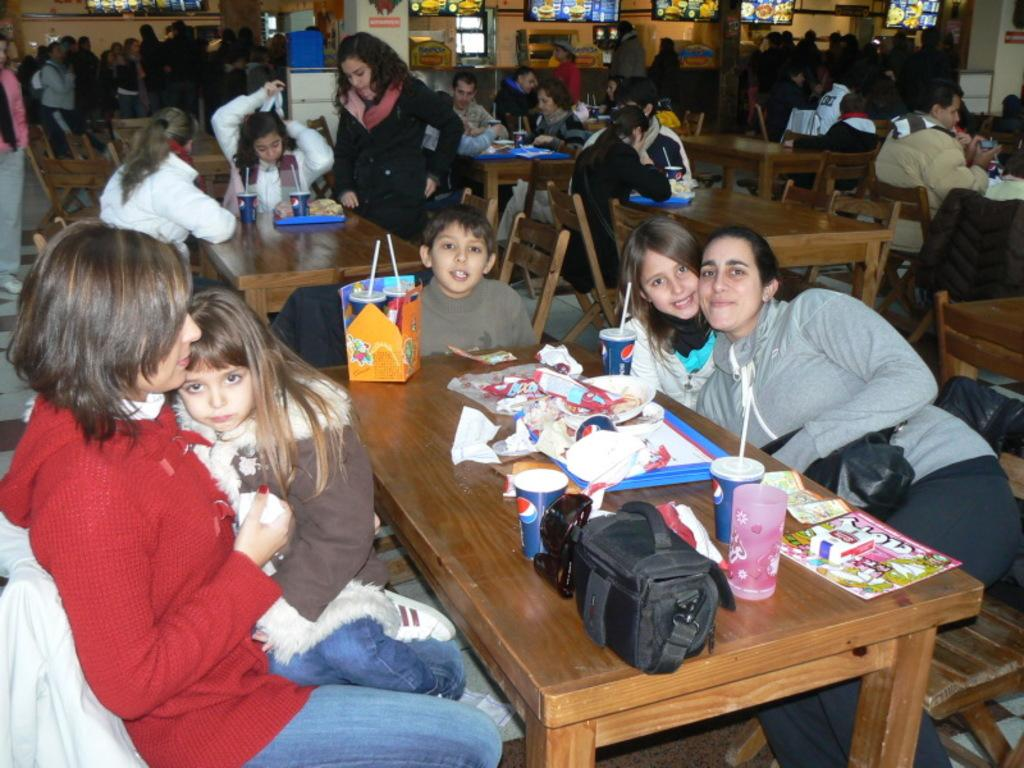How many people are in the image? There are multiple persons in the image. What are some of the people doing in the image? Some of the persons are sitting on chairs, while at least one person is standing on the floor. What is the color of the background in the image? The background color is yellow. What type of alarm can be heard going off in the image? There is no alarm present or audible in the image. Can you describe the cellar in the image? There is no cellar present in the image. 